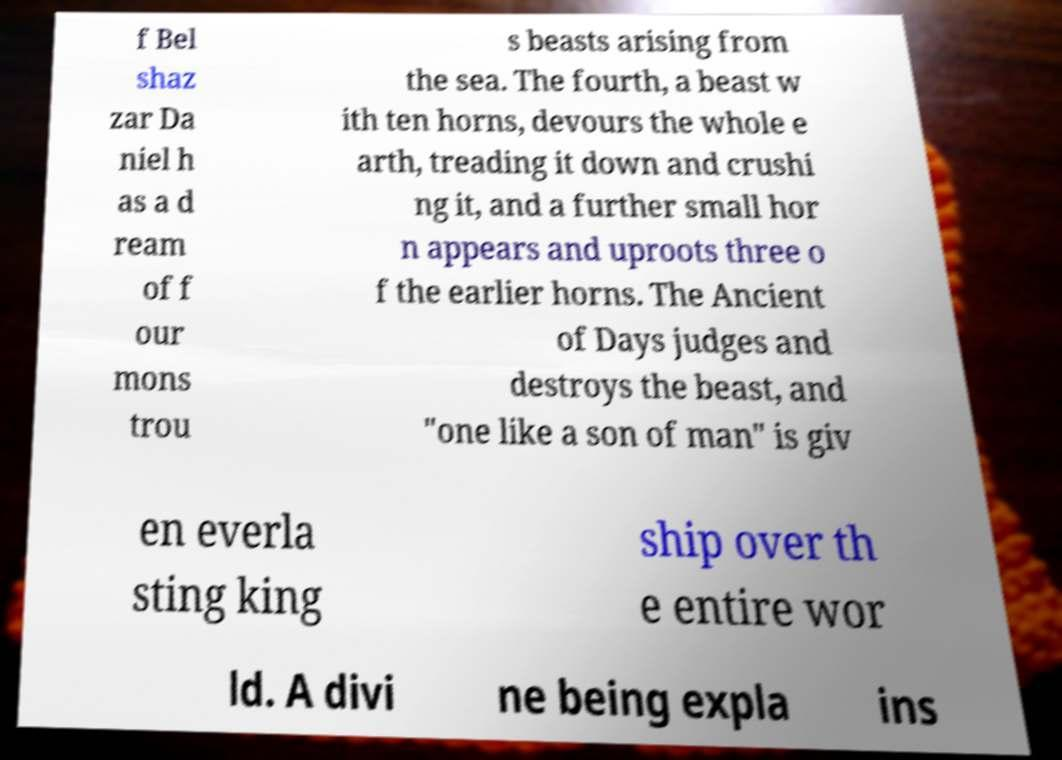For documentation purposes, I need the text within this image transcribed. Could you provide that? f Bel shaz zar Da niel h as a d ream of f our mons trou s beasts arising from the sea. The fourth, a beast w ith ten horns, devours the whole e arth, treading it down and crushi ng it, and a further small hor n appears and uproots three o f the earlier horns. The Ancient of Days judges and destroys the beast, and "one like a son of man" is giv en everla sting king ship over th e entire wor ld. A divi ne being expla ins 